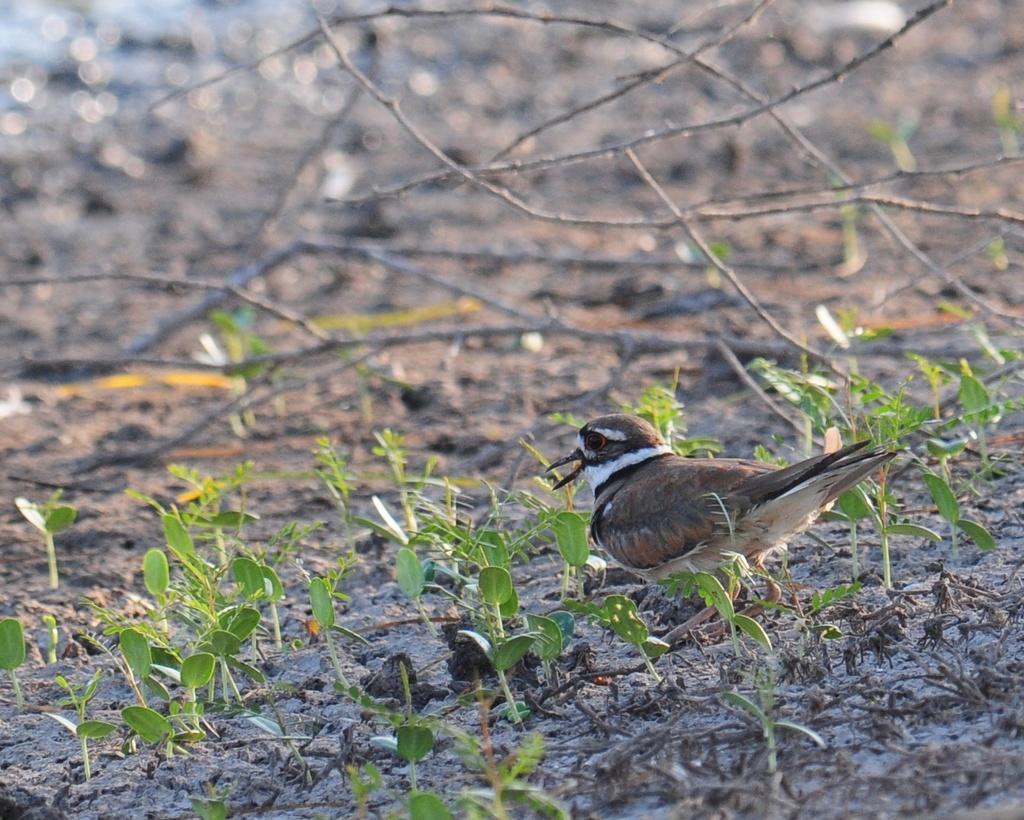How would you summarize this image in a sentence or two? In the foreground of the picture there are plants, land and a bird. In the background we can see twigs and land. On the top it is blurred. 